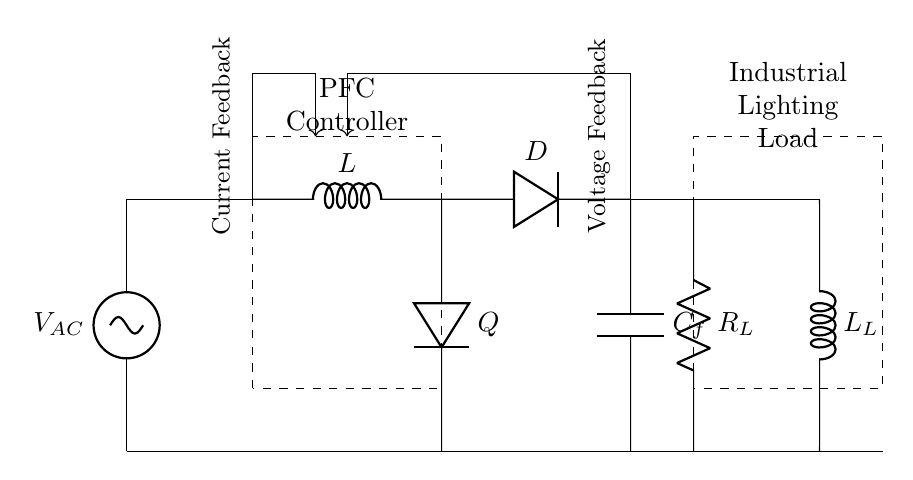What does the dashed rectangle represent? The dashed rectangle labeled "PFC Controller" indicates the section of the circuit dedicated to power factor correction, which manages the reactive power in the circuit.
Answer: PFC Controller What component is used for voltage feedback? The arrow indicating voltage feedback shows it is taken from the output of the filter capacitor connected at point (8,4), demonstrating a method to monitor and adjust the voltage levels accordingly.
Answer: Voltage Feedback What type of load is represented in the circuit? The dashed rectangle labeled "Industrial Lighting Load" represents an industrial application, where lighting is the primary load type being powered by the circuit.
Answer: Industrial Lighting Load How many inductors are present in the circuit? An examination of the circuit diagram reveals there is one inductor in the Boost Converter section, identified by the symbol given its position in the DC path.
Answer: One What is the purpose of the diode labeled Q? The diode, labeled Q, is used to allow current to flow in one direction while blocking reverse current, functioning as a rectifier in the boost converter section of the circuit.
Answer: To rectify current What is the function of the capacitor labeled C_f? The capacitor C_f is intended to smooth out voltage variations and improve the overall stability of the output voltage for the industrial lighting load by storing electrical energy temporarily.
Answer: Voltage stabilization What is the nature of the connections between the components? The connections between the components are series connections, where the current flows through them one after another, particularly observable in the flow from the AC source through the PFC controller and towards the industrial lighting load.
Answer: Series connections 